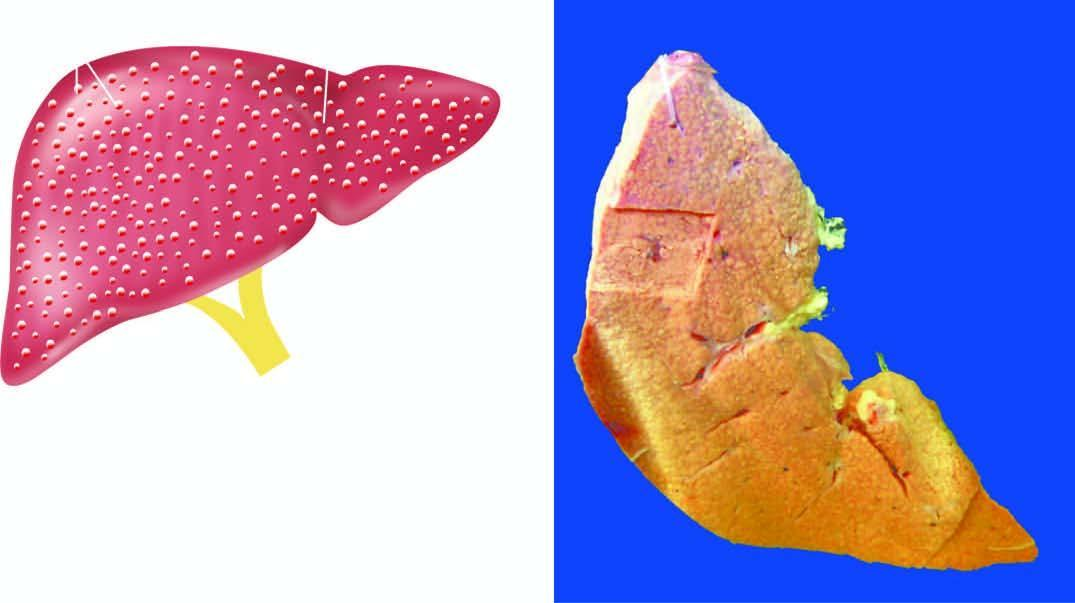s adp diffuse nodularity on sectioned surface of the liver?
Answer the question using a single word or phrase. No 